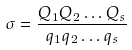<formula> <loc_0><loc_0><loc_500><loc_500>\sigma = \frac { Q _ { 1 } Q _ { 2 } \dots Q _ { s } } { q _ { 1 } q _ { 2 } \dots q _ { s } }</formula> 